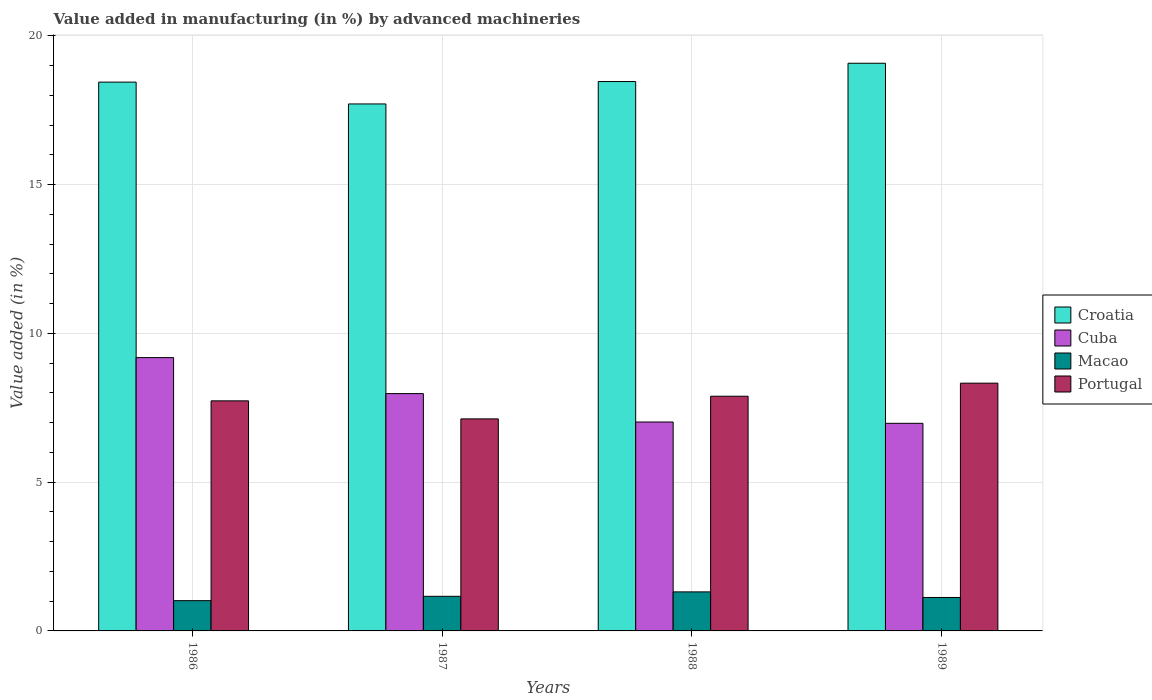How many different coloured bars are there?
Your answer should be very brief. 4. How many groups of bars are there?
Your response must be concise. 4. Are the number of bars per tick equal to the number of legend labels?
Ensure brevity in your answer.  Yes. In how many cases, is the number of bars for a given year not equal to the number of legend labels?
Your answer should be compact. 0. What is the percentage of value added in manufacturing by advanced machineries in Cuba in 1988?
Give a very brief answer. 7.02. Across all years, what is the maximum percentage of value added in manufacturing by advanced machineries in Portugal?
Your answer should be compact. 8.33. Across all years, what is the minimum percentage of value added in manufacturing by advanced machineries in Croatia?
Offer a terse response. 17.71. In which year was the percentage of value added in manufacturing by advanced machineries in Macao minimum?
Give a very brief answer. 1986. What is the total percentage of value added in manufacturing by advanced machineries in Macao in the graph?
Offer a very short reply. 4.62. What is the difference between the percentage of value added in manufacturing by advanced machineries in Cuba in 1988 and that in 1989?
Ensure brevity in your answer.  0.04. What is the difference between the percentage of value added in manufacturing by advanced machineries in Cuba in 1987 and the percentage of value added in manufacturing by advanced machineries in Croatia in 1989?
Provide a succinct answer. -11.1. What is the average percentage of value added in manufacturing by advanced machineries in Cuba per year?
Ensure brevity in your answer.  7.79. In the year 1989, what is the difference between the percentage of value added in manufacturing by advanced machineries in Portugal and percentage of value added in manufacturing by advanced machineries in Croatia?
Your answer should be compact. -10.75. In how many years, is the percentage of value added in manufacturing by advanced machineries in Croatia greater than 2 %?
Your response must be concise. 4. What is the ratio of the percentage of value added in manufacturing by advanced machineries in Macao in 1987 to that in 1989?
Keep it short and to the point. 1.03. Is the difference between the percentage of value added in manufacturing by advanced machineries in Portugal in 1986 and 1988 greater than the difference between the percentage of value added in manufacturing by advanced machineries in Croatia in 1986 and 1988?
Give a very brief answer. No. What is the difference between the highest and the second highest percentage of value added in manufacturing by advanced machineries in Portugal?
Keep it short and to the point. 0.44. What is the difference between the highest and the lowest percentage of value added in manufacturing by advanced machineries in Cuba?
Your answer should be compact. 2.21. In how many years, is the percentage of value added in manufacturing by advanced machineries in Macao greater than the average percentage of value added in manufacturing by advanced machineries in Macao taken over all years?
Your answer should be compact. 2. Is the sum of the percentage of value added in manufacturing by advanced machineries in Portugal in 1986 and 1988 greater than the maximum percentage of value added in manufacturing by advanced machineries in Cuba across all years?
Your answer should be very brief. Yes. What does the 3rd bar from the right in 1988 represents?
Give a very brief answer. Cuba. Is it the case that in every year, the sum of the percentage of value added in manufacturing by advanced machineries in Croatia and percentage of value added in manufacturing by advanced machineries in Portugal is greater than the percentage of value added in manufacturing by advanced machineries in Macao?
Provide a succinct answer. Yes. How many bars are there?
Provide a short and direct response. 16. Are all the bars in the graph horizontal?
Keep it short and to the point. No. Are the values on the major ticks of Y-axis written in scientific E-notation?
Your answer should be compact. No. Does the graph contain any zero values?
Keep it short and to the point. No. How many legend labels are there?
Make the answer very short. 4. How are the legend labels stacked?
Ensure brevity in your answer.  Vertical. What is the title of the graph?
Provide a short and direct response. Value added in manufacturing (in %) by advanced machineries. What is the label or title of the Y-axis?
Your answer should be very brief. Value added (in %). What is the Value added (in %) of Croatia in 1986?
Give a very brief answer. 18.44. What is the Value added (in %) in Cuba in 1986?
Provide a short and direct response. 9.18. What is the Value added (in %) of Macao in 1986?
Offer a very short reply. 1.02. What is the Value added (in %) in Portugal in 1986?
Ensure brevity in your answer.  7.73. What is the Value added (in %) in Croatia in 1987?
Your answer should be very brief. 17.71. What is the Value added (in %) of Cuba in 1987?
Give a very brief answer. 7.97. What is the Value added (in %) of Macao in 1987?
Your answer should be compact. 1.16. What is the Value added (in %) in Portugal in 1987?
Your response must be concise. 7.13. What is the Value added (in %) in Croatia in 1988?
Your response must be concise. 18.46. What is the Value added (in %) in Cuba in 1988?
Your answer should be very brief. 7.02. What is the Value added (in %) of Macao in 1988?
Give a very brief answer. 1.31. What is the Value added (in %) of Portugal in 1988?
Provide a succinct answer. 7.89. What is the Value added (in %) in Croatia in 1989?
Provide a succinct answer. 19.08. What is the Value added (in %) of Cuba in 1989?
Offer a terse response. 6.98. What is the Value added (in %) in Macao in 1989?
Your response must be concise. 1.12. What is the Value added (in %) in Portugal in 1989?
Offer a terse response. 8.33. Across all years, what is the maximum Value added (in %) of Croatia?
Offer a terse response. 19.08. Across all years, what is the maximum Value added (in %) of Cuba?
Ensure brevity in your answer.  9.18. Across all years, what is the maximum Value added (in %) of Macao?
Give a very brief answer. 1.31. Across all years, what is the maximum Value added (in %) of Portugal?
Give a very brief answer. 8.33. Across all years, what is the minimum Value added (in %) in Croatia?
Ensure brevity in your answer.  17.71. Across all years, what is the minimum Value added (in %) of Cuba?
Your answer should be very brief. 6.98. Across all years, what is the minimum Value added (in %) in Macao?
Provide a succinct answer. 1.02. Across all years, what is the minimum Value added (in %) in Portugal?
Provide a short and direct response. 7.13. What is the total Value added (in %) of Croatia in the graph?
Give a very brief answer. 73.69. What is the total Value added (in %) of Cuba in the graph?
Make the answer very short. 31.16. What is the total Value added (in %) in Macao in the graph?
Your response must be concise. 4.62. What is the total Value added (in %) in Portugal in the graph?
Your answer should be compact. 31.07. What is the difference between the Value added (in %) of Croatia in 1986 and that in 1987?
Provide a short and direct response. 0.73. What is the difference between the Value added (in %) in Cuba in 1986 and that in 1987?
Your answer should be very brief. 1.21. What is the difference between the Value added (in %) of Macao in 1986 and that in 1987?
Keep it short and to the point. -0.15. What is the difference between the Value added (in %) in Portugal in 1986 and that in 1987?
Make the answer very short. 0.61. What is the difference between the Value added (in %) in Croatia in 1986 and that in 1988?
Provide a short and direct response. -0.02. What is the difference between the Value added (in %) of Cuba in 1986 and that in 1988?
Keep it short and to the point. 2.16. What is the difference between the Value added (in %) in Macao in 1986 and that in 1988?
Offer a very short reply. -0.29. What is the difference between the Value added (in %) of Portugal in 1986 and that in 1988?
Provide a succinct answer. -0.16. What is the difference between the Value added (in %) in Croatia in 1986 and that in 1989?
Your answer should be compact. -0.63. What is the difference between the Value added (in %) of Cuba in 1986 and that in 1989?
Give a very brief answer. 2.21. What is the difference between the Value added (in %) of Macao in 1986 and that in 1989?
Give a very brief answer. -0.11. What is the difference between the Value added (in %) of Portugal in 1986 and that in 1989?
Your answer should be compact. -0.59. What is the difference between the Value added (in %) of Croatia in 1987 and that in 1988?
Provide a succinct answer. -0.75. What is the difference between the Value added (in %) of Cuba in 1987 and that in 1988?
Offer a terse response. 0.95. What is the difference between the Value added (in %) of Macao in 1987 and that in 1988?
Provide a short and direct response. -0.15. What is the difference between the Value added (in %) of Portugal in 1987 and that in 1988?
Your answer should be compact. -0.76. What is the difference between the Value added (in %) in Croatia in 1987 and that in 1989?
Your response must be concise. -1.37. What is the difference between the Value added (in %) in Cuba in 1987 and that in 1989?
Provide a succinct answer. 1. What is the difference between the Value added (in %) in Macao in 1987 and that in 1989?
Offer a very short reply. 0.04. What is the difference between the Value added (in %) in Portugal in 1987 and that in 1989?
Provide a succinct answer. -1.2. What is the difference between the Value added (in %) in Croatia in 1988 and that in 1989?
Keep it short and to the point. -0.61. What is the difference between the Value added (in %) in Cuba in 1988 and that in 1989?
Offer a very short reply. 0.04. What is the difference between the Value added (in %) in Macao in 1988 and that in 1989?
Offer a terse response. 0.19. What is the difference between the Value added (in %) of Portugal in 1988 and that in 1989?
Provide a short and direct response. -0.44. What is the difference between the Value added (in %) of Croatia in 1986 and the Value added (in %) of Cuba in 1987?
Provide a succinct answer. 10.47. What is the difference between the Value added (in %) in Croatia in 1986 and the Value added (in %) in Macao in 1987?
Make the answer very short. 17.28. What is the difference between the Value added (in %) of Croatia in 1986 and the Value added (in %) of Portugal in 1987?
Provide a short and direct response. 11.32. What is the difference between the Value added (in %) of Cuba in 1986 and the Value added (in %) of Macao in 1987?
Make the answer very short. 8.02. What is the difference between the Value added (in %) of Cuba in 1986 and the Value added (in %) of Portugal in 1987?
Make the answer very short. 2.06. What is the difference between the Value added (in %) in Macao in 1986 and the Value added (in %) in Portugal in 1987?
Make the answer very short. -6.11. What is the difference between the Value added (in %) of Croatia in 1986 and the Value added (in %) of Cuba in 1988?
Your response must be concise. 11.42. What is the difference between the Value added (in %) in Croatia in 1986 and the Value added (in %) in Macao in 1988?
Keep it short and to the point. 17.13. What is the difference between the Value added (in %) of Croatia in 1986 and the Value added (in %) of Portugal in 1988?
Keep it short and to the point. 10.56. What is the difference between the Value added (in %) of Cuba in 1986 and the Value added (in %) of Macao in 1988?
Your answer should be very brief. 7.87. What is the difference between the Value added (in %) of Cuba in 1986 and the Value added (in %) of Portugal in 1988?
Your answer should be very brief. 1.3. What is the difference between the Value added (in %) of Macao in 1986 and the Value added (in %) of Portugal in 1988?
Provide a succinct answer. -6.87. What is the difference between the Value added (in %) of Croatia in 1986 and the Value added (in %) of Cuba in 1989?
Keep it short and to the point. 11.47. What is the difference between the Value added (in %) in Croatia in 1986 and the Value added (in %) in Macao in 1989?
Your answer should be very brief. 17.32. What is the difference between the Value added (in %) of Croatia in 1986 and the Value added (in %) of Portugal in 1989?
Make the answer very short. 10.12. What is the difference between the Value added (in %) of Cuba in 1986 and the Value added (in %) of Macao in 1989?
Make the answer very short. 8.06. What is the difference between the Value added (in %) of Cuba in 1986 and the Value added (in %) of Portugal in 1989?
Provide a succinct answer. 0.86. What is the difference between the Value added (in %) of Macao in 1986 and the Value added (in %) of Portugal in 1989?
Your answer should be compact. -7.31. What is the difference between the Value added (in %) in Croatia in 1987 and the Value added (in %) in Cuba in 1988?
Your answer should be very brief. 10.69. What is the difference between the Value added (in %) in Croatia in 1987 and the Value added (in %) in Macao in 1988?
Give a very brief answer. 16.4. What is the difference between the Value added (in %) in Croatia in 1987 and the Value added (in %) in Portugal in 1988?
Your answer should be very brief. 9.82. What is the difference between the Value added (in %) of Cuba in 1987 and the Value added (in %) of Macao in 1988?
Provide a short and direct response. 6.66. What is the difference between the Value added (in %) in Cuba in 1987 and the Value added (in %) in Portugal in 1988?
Give a very brief answer. 0.09. What is the difference between the Value added (in %) of Macao in 1987 and the Value added (in %) of Portugal in 1988?
Offer a very short reply. -6.72. What is the difference between the Value added (in %) in Croatia in 1987 and the Value added (in %) in Cuba in 1989?
Offer a terse response. 10.73. What is the difference between the Value added (in %) of Croatia in 1987 and the Value added (in %) of Macao in 1989?
Keep it short and to the point. 16.58. What is the difference between the Value added (in %) of Croatia in 1987 and the Value added (in %) of Portugal in 1989?
Ensure brevity in your answer.  9.38. What is the difference between the Value added (in %) in Cuba in 1987 and the Value added (in %) in Macao in 1989?
Your answer should be very brief. 6.85. What is the difference between the Value added (in %) of Cuba in 1987 and the Value added (in %) of Portugal in 1989?
Keep it short and to the point. -0.35. What is the difference between the Value added (in %) of Macao in 1987 and the Value added (in %) of Portugal in 1989?
Ensure brevity in your answer.  -7.16. What is the difference between the Value added (in %) in Croatia in 1988 and the Value added (in %) in Cuba in 1989?
Your answer should be compact. 11.49. What is the difference between the Value added (in %) in Croatia in 1988 and the Value added (in %) in Macao in 1989?
Offer a very short reply. 17.34. What is the difference between the Value added (in %) of Croatia in 1988 and the Value added (in %) of Portugal in 1989?
Provide a succinct answer. 10.14. What is the difference between the Value added (in %) of Cuba in 1988 and the Value added (in %) of Macao in 1989?
Offer a very short reply. 5.9. What is the difference between the Value added (in %) in Cuba in 1988 and the Value added (in %) in Portugal in 1989?
Ensure brevity in your answer.  -1.31. What is the difference between the Value added (in %) of Macao in 1988 and the Value added (in %) of Portugal in 1989?
Offer a terse response. -7.01. What is the average Value added (in %) of Croatia per year?
Your answer should be compact. 18.42. What is the average Value added (in %) of Cuba per year?
Provide a succinct answer. 7.79. What is the average Value added (in %) of Macao per year?
Offer a terse response. 1.15. What is the average Value added (in %) of Portugal per year?
Give a very brief answer. 7.77. In the year 1986, what is the difference between the Value added (in %) in Croatia and Value added (in %) in Cuba?
Provide a succinct answer. 9.26. In the year 1986, what is the difference between the Value added (in %) in Croatia and Value added (in %) in Macao?
Keep it short and to the point. 17.43. In the year 1986, what is the difference between the Value added (in %) in Croatia and Value added (in %) in Portugal?
Your answer should be compact. 10.71. In the year 1986, what is the difference between the Value added (in %) in Cuba and Value added (in %) in Macao?
Keep it short and to the point. 8.17. In the year 1986, what is the difference between the Value added (in %) in Cuba and Value added (in %) in Portugal?
Give a very brief answer. 1.45. In the year 1986, what is the difference between the Value added (in %) in Macao and Value added (in %) in Portugal?
Ensure brevity in your answer.  -6.71. In the year 1987, what is the difference between the Value added (in %) in Croatia and Value added (in %) in Cuba?
Your response must be concise. 9.73. In the year 1987, what is the difference between the Value added (in %) in Croatia and Value added (in %) in Macao?
Ensure brevity in your answer.  16.55. In the year 1987, what is the difference between the Value added (in %) of Croatia and Value added (in %) of Portugal?
Your answer should be compact. 10.58. In the year 1987, what is the difference between the Value added (in %) in Cuba and Value added (in %) in Macao?
Make the answer very short. 6.81. In the year 1987, what is the difference between the Value added (in %) in Cuba and Value added (in %) in Portugal?
Offer a very short reply. 0.85. In the year 1987, what is the difference between the Value added (in %) in Macao and Value added (in %) in Portugal?
Provide a succinct answer. -5.96. In the year 1988, what is the difference between the Value added (in %) of Croatia and Value added (in %) of Cuba?
Your answer should be compact. 11.44. In the year 1988, what is the difference between the Value added (in %) in Croatia and Value added (in %) in Macao?
Provide a succinct answer. 17.15. In the year 1988, what is the difference between the Value added (in %) in Croatia and Value added (in %) in Portugal?
Give a very brief answer. 10.57. In the year 1988, what is the difference between the Value added (in %) in Cuba and Value added (in %) in Macao?
Your answer should be very brief. 5.71. In the year 1988, what is the difference between the Value added (in %) in Cuba and Value added (in %) in Portugal?
Give a very brief answer. -0.87. In the year 1988, what is the difference between the Value added (in %) in Macao and Value added (in %) in Portugal?
Your answer should be very brief. -6.58. In the year 1989, what is the difference between the Value added (in %) in Croatia and Value added (in %) in Cuba?
Make the answer very short. 12.1. In the year 1989, what is the difference between the Value added (in %) of Croatia and Value added (in %) of Macao?
Give a very brief answer. 17.95. In the year 1989, what is the difference between the Value added (in %) of Croatia and Value added (in %) of Portugal?
Give a very brief answer. 10.75. In the year 1989, what is the difference between the Value added (in %) of Cuba and Value added (in %) of Macao?
Keep it short and to the point. 5.85. In the year 1989, what is the difference between the Value added (in %) of Cuba and Value added (in %) of Portugal?
Provide a short and direct response. -1.35. In the year 1989, what is the difference between the Value added (in %) of Macao and Value added (in %) of Portugal?
Give a very brief answer. -7.2. What is the ratio of the Value added (in %) of Croatia in 1986 to that in 1987?
Keep it short and to the point. 1.04. What is the ratio of the Value added (in %) in Cuba in 1986 to that in 1987?
Your response must be concise. 1.15. What is the ratio of the Value added (in %) in Macao in 1986 to that in 1987?
Ensure brevity in your answer.  0.87. What is the ratio of the Value added (in %) of Portugal in 1986 to that in 1987?
Provide a short and direct response. 1.08. What is the ratio of the Value added (in %) of Croatia in 1986 to that in 1988?
Your answer should be compact. 1. What is the ratio of the Value added (in %) of Cuba in 1986 to that in 1988?
Provide a succinct answer. 1.31. What is the ratio of the Value added (in %) in Macao in 1986 to that in 1988?
Give a very brief answer. 0.78. What is the ratio of the Value added (in %) in Portugal in 1986 to that in 1988?
Your response must be concise. 0.98. What is the ratio of the Value added (in %) of Croatia in 1986 to that in 1989?
Your answer should be compact. 0.97. What is the ratio of the Value added (in %) of Cuba in 1986 to that in 1989?
Give a very brief answer. 1.32. What is the ratio of the Value added (in %) in Macao in 1986 to that in 1989?
Your response must be concise. 0.9. What is the ratio of the Value added (in %) of Portugal in 1986 to that in 1989?
Keep it short and to the point. 0.93. What is the ratio of the Value added (in %) of Croatia in 1987 to that in 1988?
Make the answer very short. 0.96. What is the ratio of the Value added (in %) of Cuba in 1987 to that in 1988?
Give a very brief answer. 1.14. What is the ratio of the Value added (in %) of Macao in 1987 to that in 1988?
Provide a short and direct response. 0.89. What is the ratio of the Value added (in %) in Portugal in 1987 to that in 1988?
Your response must be concise. 0.9. What is the ratio of the Value added (in %) in Croatia in 1987 to that in 1989?
Provide a succinct answer. 0.93. What is the ratio of the Value added (in %) of Cuba in 1987 to that in 1989?
Provide a succinct answer. 1.14. What is the ratio of the Value added (in %) of Macao in 1987 to that in 1989?
Give a very brief answer. 1.03. What is the ratio of the Value added (in %) of Portugal in 1987 to that in 1989?
Provide a short and direct response. 0.86. What is the ratio of the Value added (in %) of Croatia in 1988 to that in 1989?
Make the answer very short. 0.97. What is the ratio of the Value added (in %) in Cuba in 1988 to that in 1989?
Keep it short and to the point. 1.01. What is the ratio of the Value added (in %) of Macao in 1988 to that in 1989?
Give a very brief answer. 1.17. What is the ratio of the Value added (in %) in Portugal in 1988 to that in 1989?
Keep it short and to the point. 0.95. What is the difference between the highest and the second highest Value added (in %) of Croatia?
Ensure brevity in your answer.  0.61. What is the difference between the highest and the second highest Value added (in %) in Cuba?
Provide a succinct answer. 1.21. What is the difference between the highest and the second highest Value added (in %) in Macao?
Offer a very short reply. 0.15. What is the difference between the highest and the second highest Value added (in %) of Portugal?
Ensure brevity in your answer.  0.44. What is the difference between the highest and the lowest Value added (in %) in Croatia?
Make the answer very short. 1.37. What is the difference between the highest and the lowest Value added (in %) of Cuba?
Your response must be concise. 2.21. What is the difference between the highest and the lowest Value added (in %) of Macao?
Make the answer very short. 0.29. What is the difference between the highest and the lowest Value added (in %) of Portugal?
Keep it short and to the point. 1.2. 